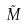<formula> <loc_0><loc_0><loc_500><loc_500>\tilde { M }</formula> 